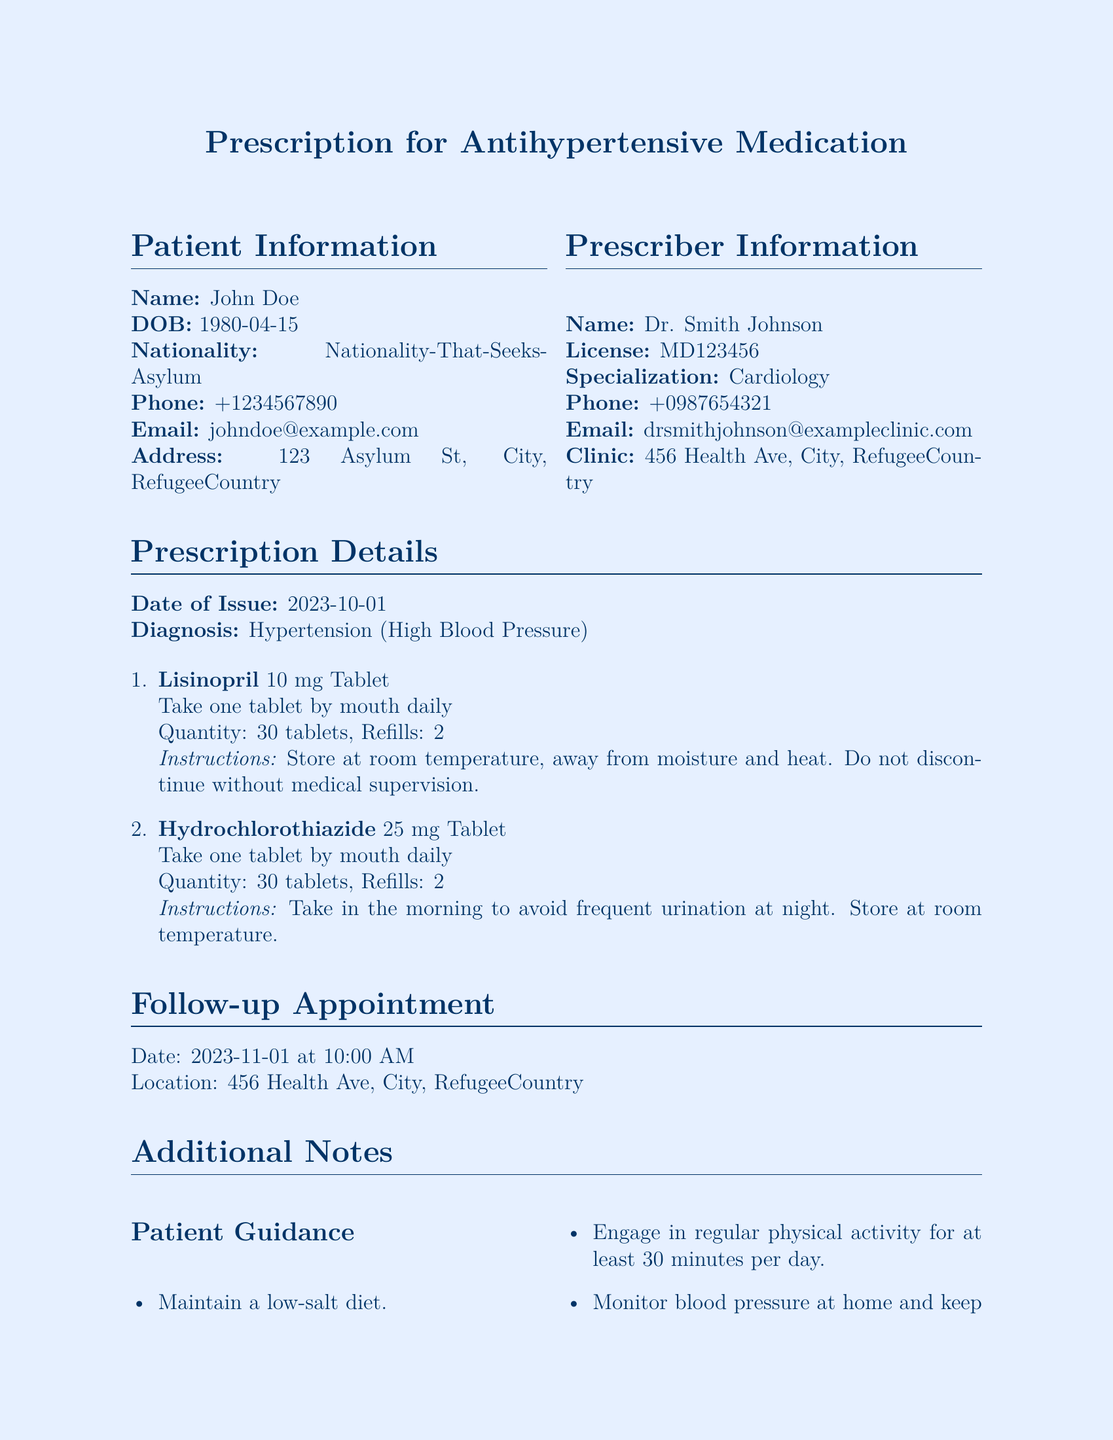What is the patient's name? The patient's name is listed in the Patient Information section of the document.
Answer: John Doe What is the prescribed medication for hypertension? The prescription includes two medications for hypertension.
Answer: Lisinopril and Hydrochlorothiazide What is the dosage of Lisinopril? The dosage details for Lisinopril can be found in the Prescription Details section.
Answer: 10 mg Tablet When is the follow-up appointment scheduled? The date of the follow-up appointment is mentioned in the Follow-up Appointment section.
Answer: 2023-11-01 How many refills are allowed for Hydrochlorothiazide? This information can be found in the prescription details concerning Hydrochlorothiazide.
Answer: 2 What instructions are given for taking Hydrochlorothiazide? The instructions for Hydrochlorothiazide can be found in the Prescription Details section.
Answer: Take in the morning to avoid frequent urination at night What is the doctor's name who issued the prescription? The doctor's name is in the Prescriber Information section of the document.
Answer: Dr. Smith Johnson What type of dietary recommendation is provided for the patient? The dietary guidance is listed under Patient Guidance.
Answer: Maintain a low-salt diet Are translation services offered at the clinic? This information can be found in the Language Access Services section of the document.
Answer: Yes 